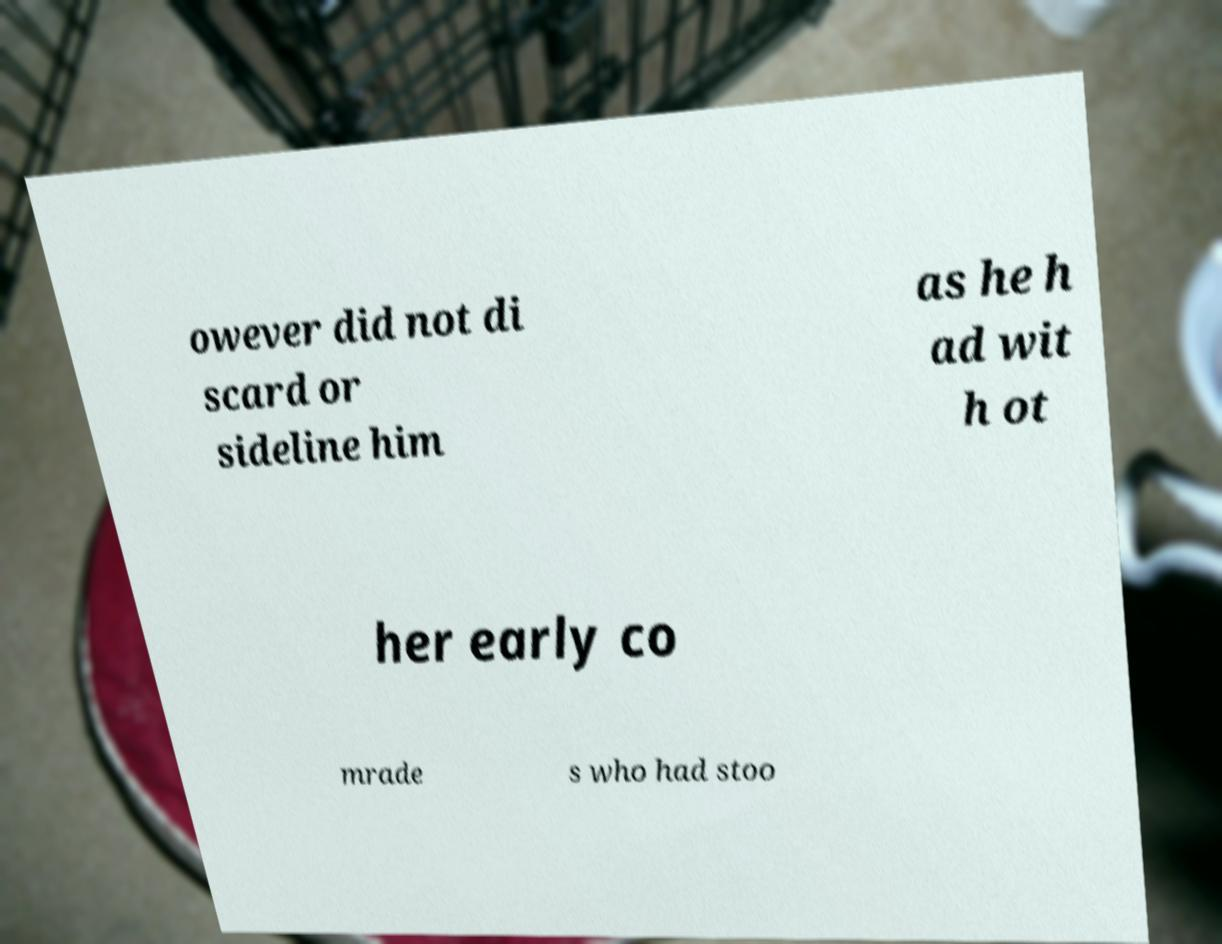What messages or text are displayed in this image? I need them in a readable, typed format. owever did not di scard or sideline him as he h ad wit h ot her early co mrade s who had stoo 